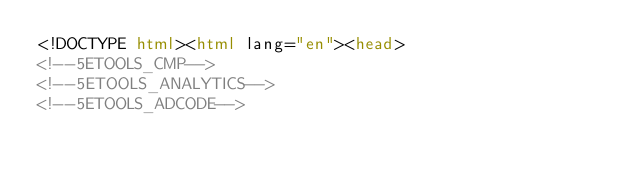<code> <loc_0><loc_0><loc_500><loc_500><_HTML_><!DOCTYPE html><html lang="en"><head>
<!--5ETOOLS_CMP-->
<!--5ETOOLS_ANALYTICS-->
<!--5ETOOLS_ADCODE--></code> 